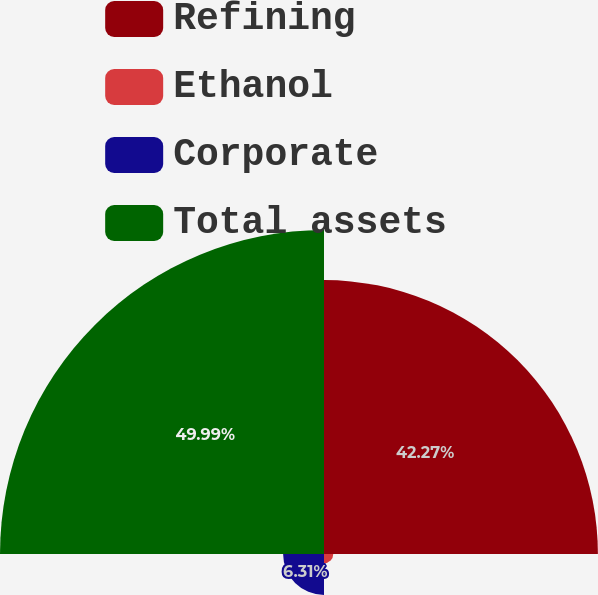Convert chart to OTSL. <chart><loc_0><loc_0><loc_500><loc_500><pie_chart><fcel>Refining<fcel>Ethanol<fcel>Corporate<fcel>Total assets<nl><fcel>42.27%<fcel>1.43%<fcel>6.31%<fcel>50.0%<nl></chart> 